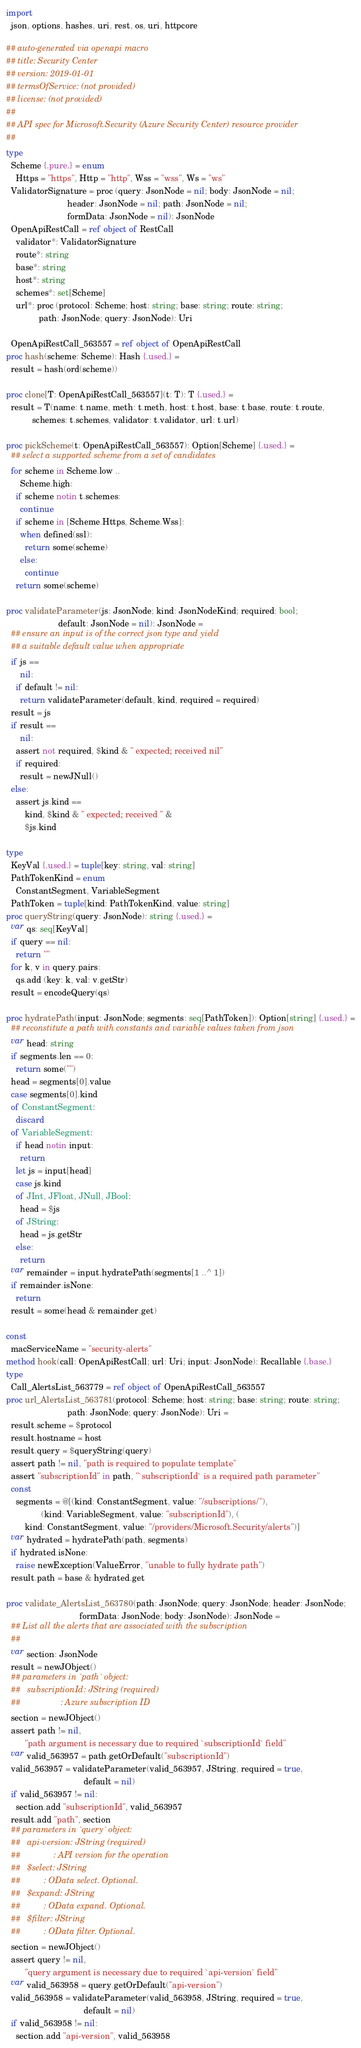Convert code to text. <code><loc_0><loc_0><loc_500><loc_500><_Nim_>
import
  json, options, hashes, uri, rest, os, uri, httpcore

## auto-generated via openapi macro
## title: Security Center
## version: 2019-01-01
## termsOfService: (not provided)
## license: (not provided)
## 
## API spec for Microsoft.Security (Azure Security Center) resource provider
## 
type
  Scheme {.pure.} = enum
    Https = "https", Http = "http", Wss = "wss", Ws = "ws"
  ValidatorSignature = proc (query: JsonNode = nil; body: JsonNode = nil;
                          header: JsonNode = nil; path: JsonNode = nil;
                          formData: JsonNode = nil): JsonNode
  OpenApiRestCall = ref object of RestCall
    validator*: ValidatorSignature
    route*: string
    base*: string
    host*: string
    schemes*: set[Scheme]
    url*: proc (protocol: Scheme; host: string; base: string; route: string;
              path: JsonNode; query: JsonNode): Uri

  OpenApiRestCall_563557 = ref object of OpenApiRestCall
proc hash(scheme: Scheme): Hash {.used.} =
  result = hash(ord(scheme))

proc clone[T: OpenApiRestCall_563557](t: T): T {.used.} =
  result = T(name: t.name, meth: t.meth, host: t.host, base: t.base, route: t.route,
           schemes: t.schemes, validator: t.validator, url: t.url)

proc pickScheme(t: OpenApiRestCall_563557): Option[Scheme] {.used.} =
  ## select a supported scheme from a set of candidates
  for scheme in Scheme.low ..
      Scheme.high:
    if scheme notin t.schemes:
      continue
    if scheme in [Scheme.Https, Scheme.Wss]:
      when defined(ssl):
        return some(scheme)
      else:
        continue
    return some(scheme)

proc validateParameter(js: JsonNode; kind: JsonNodeKind; required: bool;
                      default: JsonNode = nil): JsonNode =
  ## ensure an input is of the correct json type and yield
  ## a suitable default value when appropriate
  if js ==
      nil:
    if default != nil:
      return validateParameter(default, kind, required = required)
  result = js
  if result ==
      nil:
    assert not required, $kind & " expected; received nil"
    if required:
      result = newJNull()
  else:
    assert js.kind ==
        kind, $kind & " expected; received " &
        $js.kind

type
  KeyVal {.used.} = tuple[key: string, val: string]
  PathTokenKind = enum
    ConstantSegment, VariableSegment
  PathToken = tuple[kind: PathTokenKind, value: string]
proc queryString(query: JsonNode): string {.used.} =
  var qs: seq[KeyVal]
  if query == nil:
    return ""
  for k, v in query.pairs:
    qs.add (key: k, val: v.getStr)
  result = encodeQuery(qs)

proc hydratePath(input: JsonNode; segments: seq[PathToken]): Option[string] {.used.} =
  ## reconstitute a path with constants and variable values taken from json
  var head: string
  if segments.len == 0:
    return some("")
  head = segments[0].value
  case segments[0].kind
  of ConstantSegment:
    discard
  of VariableSegment:
    if head notin input:
      return
    let js = input[head]
    case js.kind
    of JInt, JFloat, JNull, JBool:
      head = $js
    of JString:
      head = js.getStr
    else:
      return
  var remainder = input.hydratePath(segments[1 ..^ 1])
  if remainder.isNone:
    return
  result = some(head & remainder.get)

const
  macServiceName = "security-alerts"
method hook(call: OpenApiRestCall; url: Uri; input: JsonNode): Recallable {.base.}
type
  Call_AlertsList_563779 = ref object of OpenApiRestCall_563557
proc url_AlertsList_563781(protocol: Scheme; host: string; base: string; route: string;
                          path: JsonNode; query: JsonNode): Uri =
  result.scheme = $protocol
  result.hostname = host
  result.query = $queryString(query)
  assert path != nil, "path is required to populate template"
  assert "subscriptionId" in path, "`subscriptionId` is a required path parameter"
  const
    segments = @[(kind: ConstantSegment, value: "/subscriptions/"),
               (kind: VariableSegment, value: "subscriptionId"), (
        kind: ConstantSegment, value: "/providers/Microsoft.Security/alerts")]
  var hydrated = hydratePath(path, segments)
  if hydrated.isNone:
    raise newException(ValueError, "unable to fully hydrate path")
  result.path = base & hydrated.get

proc validate_AlertsList_563780(path: JsonNode; query: JsonNode; header: JsonNode;
                               formData: JsonNode; body: JsonNode): JsonNode =
  ## List all the alerts that are associated with the subscription
  ## 
  var section: JsonNode
  result = newJObject()
  ## parameters in `path` object:
  ##   subscriptionId: JString (required)
  ##                 : Azure subscription ID
  section = newJObject()
  assert path != nil,
        "path argument is necessary due to required `subscriptionId` field"
  var valid_563957 = path.getOrDefault("subscriptionId")
  valid_563957 = validateParameter(valid_563957, JString, required = true,
                                 default = nil)
  if valid_563957 != nil:
    section.add "subscriptionId", valid_563957
  result.add "path", section
  ## parameters in `query` object:
  ##   api-version: JString (required)
  ##              : API version for the operation
  ##   $select: JString
  ##          : OData select. Optional.
  ##   $expand: JString
  ##          : OData expand. Optional.
  ##   $filter: JString
  ##          : OData filter. Optional.
  section = newJObject()
  assert query != nil,
        "query argument is necessary due to required `api-version` field"
  var valid_563958 = query.getOrDefault("api-version")
  valid_563958 = validateParameter(valid_563958, JString, required = true,
                                 default = nil)
  if valid_563958 != nil:
    section.add "api-version", valid_563958</code> 